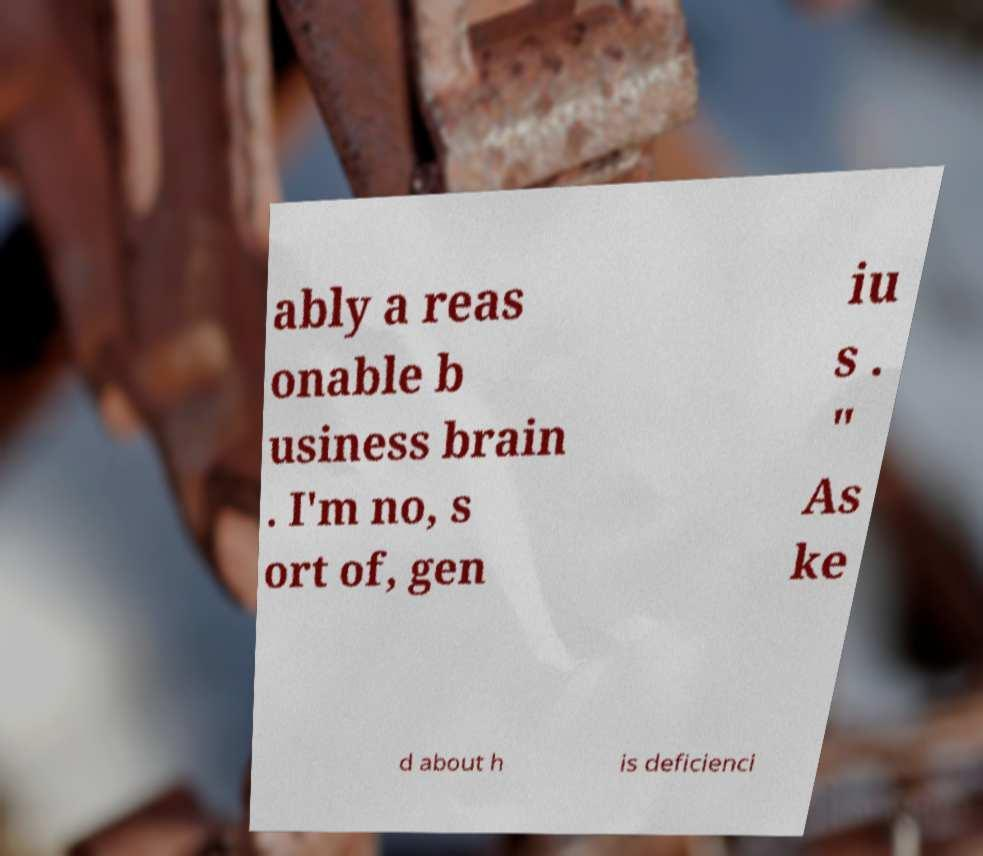For documentation purposes, I need the text within this image transcribed. Could you provide that? ably a reas onable b usiness brain . I'm no, s ort of, gen iu s . " As ke d about h is deficienci 